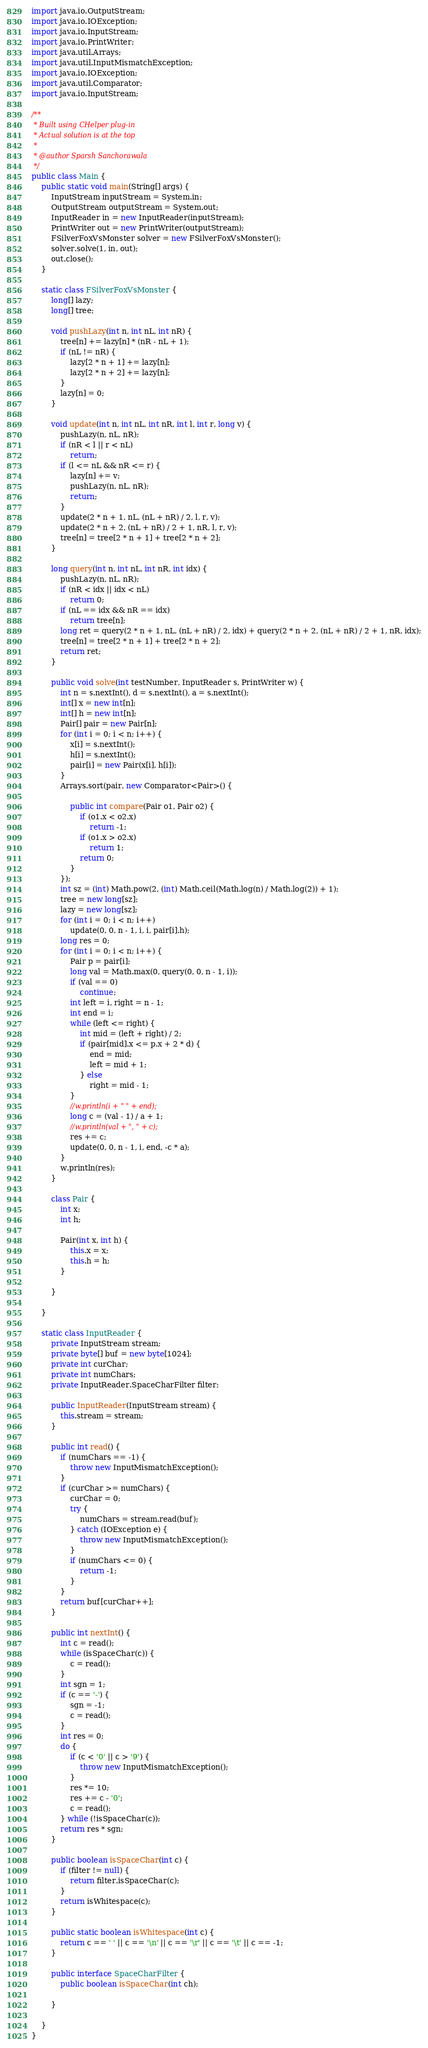<code> <loc_0><loc_0><loc_500><loc_500><_Java_>import java.io.OutputStream;
import java.io.IOException;
import java.io.InputStream;
import java.io.PrintWriter;
import java.util.Arrays;
import java.util.InputMismatchException;
import java.io.IOException;
import java.util.Comparator;
import java.io.InputStream;

/**
 * Built using CHelper plug-in
 * Actual solution is at the top
 *
 * @author Sparsh Sanchorawala
 */
public class Main {
    public static void main(String[] args) {
        InputStream inputStream = System.in;
        OutputStream outputStream = System.out;
        InputReader in = new InputReader(inputStream);
        PrintWriter out = new PrintWriter(outputStream);
        FSilverFoxVsMonster solver = new FSilverFoxVsMonster();
        solver.solve(1, in, out);
        out.close();
    }

    static class FSilverFoxVsMonster {
        long[] lazy;
        long[] tree;

        void pushLazy(int n, int nL, int nR) {
            tree[n] += lazy[n] * (nR - nL + 1);
            if (nL != nR) {
                lazy[2 * n + 1] += lazy[n];
                lazy[2 * n + 2] += lazy[n];
            }
            lazy[n] = 0;
        }

        void update(int n, int nL, int nR, int l, int r, long v) {
            pushLazy(n, nL, nR);
            if (nR < l || r < nL)
                return;
            if (l <= nL && nR <= r) {
                lazy[n] += v;
                pushLazy(n, nL, nR);
                return;
            }
            update(2 * n + 1, nL, (nL + nR) / 2, l, r, v);
            update(2 * n + 2, (nL + nR) / 2 + 1, nR, l, r, v);
            tree[n] = tree[2 * n + 1] + tree[2 * n + 2];
        }

        long query(int n, int nL, int nR, int idx) {
            pushLazy(n, nL, nR);
            if (nR < idx || idx < nL)
                return 0;
            if (nL == idx && nR == idx)
                return tree[n];
            long ret = query(2 * n + 1, nL, (nL + nR) / 2, idx) + query(2 * n + 2, (nL + nR) / 2 + 1, nR, idx);
            tree[n] = tree[2 * n + 1] + tree[2 * n + 2];
            return ret;
        }

        public void solve(int testNumber, InputReader s, PrintWriter w) {
            int n = s.nextInt(), d = s.nextInt(), a = s.nextInt();
            int[] x = new int[n];
            int[] h = new int[n];
            Pair[] pair = new Pair[n];
            for (int i = 0; i < n; i++) {
                x[i] = s.nextInt();
                h[i] = s.nextInt();
                pair[i] = new Pair(x[i], h[i]);
            }
            Arrays.sort(pair, new Comparator<Pair>() {

                public int compare(Pair o1, Pair o2) {
                    if (o1.x < o2.x)
                        return -1;
                    if (o1.x > o2.x)
                        return 1;
                    return 0;
                }
            });
            int sz = (int) Math.pow(2, (int) Math.ceil(Math.log(n) / Math.log(2)) + 1);
            tree = new long[sz];
            lazy = new long[sz];
            for (int i = 0; i < n; i++)
                update(0, 0, n - 1, i, i, pair[i].h);
            long res = 0;
            for (int i = 0; i < n; i++) {
                Pair p = pair[i];
                long val = Math.max(0, query(0, 0, n - 1, i));
                if (val == 0)
                    continue;
                int left = i, right = n - 1;
                int end = i;
                while (left <= right) {
                    int mid = (left + right) / 2;
                    if (pair[mid].x <= p.x + 2 * d) {
                        end = mid;
                        left = mid + 1;
                    } else
                        right = mid - 1;
                }
                //w.println(i + " " + end);
                long c = (val - 1) / a + 1;
                //w.println(val + ", " + c);
                res += c;
                update(0, 0, n - 1, i, end, -c * a);
            }
            w.println(res);
        }

        class Pair {
            int x;
            int h;

            Pair(int x, int h) {
                this.x = x;
                this.h = h;
            }

        }

    }

    static class InputReader {
        private InputStream stream;
        private byte[] buf = new byte[1024];
        private int curChar;
        private int numChars;
        private InputReader.SpaceCharFilter filter;

        public InputReader(InputStream stream) {
            this.stream = stream;
        }

        public int read() {
            if (numChars == -1) {
                throw new InputMismatchException();
            }
            if (curChar >= numChars) {
                curChar = 0;
                try {
                    numChars = stream.read(buf);
                } catch (IOException e) {
                    throw new InputMismatchException();
                }
                if (numChars <= 0) {
                    return -1;
                }
            }
            return buf[curChar++];
        }

        public int nextInt() {
            int c = read();
            while (isSpaceChar(c)) {
                c = read();
            }
            int sgn = 1;
            if (c == '-') {
                sgn = -1;
                c = read();
            }
            int res = 0;
            do {
                if (c < '0' || c > '9') {
                    throw new InputMismatchException();
                }
                res *= 10;
                res += c - '0';
                c = read();
            } while (!isSpaceChar(c));
            return res * sgn;
        }

        public boolean isSpaceChar(int c) {
            if (filter != null) {
                return filter.isSpaceChar(c);
            }
            return isWhitespace(c);
        }

        public static boolean isWhitespace(int c) {
            return c == ' ' || c == '\n' || c == '\r' || c == '\t' || c == -1;
        }

        public interface SpaceCharFilter {
            public boolean isSpaceChar(int ch);

        }

    }
}

</code> 